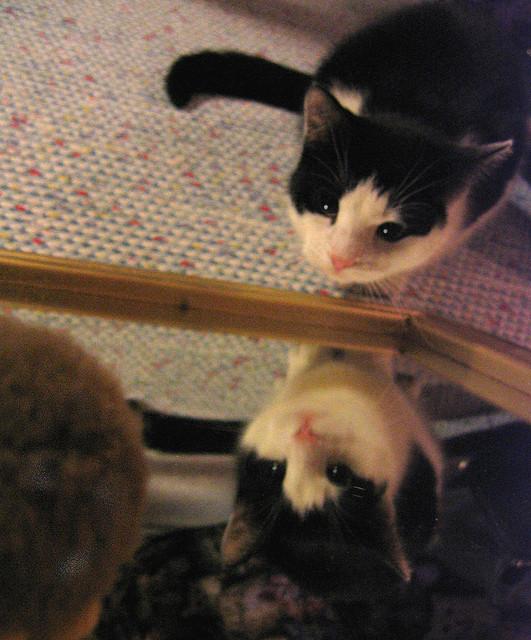What is the cat in the picture looking at?
Give a very brief answer. Person. Is the cat's nose pink?
Short answer required. Yes. What color nose does the cat have?
Short answer required. Pink. How many cats are in this picture?
Answer briefly. 1. 